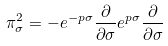<formula> <loc_0><loc_0><loc_500><loc_500>\pi _ { \sigma } ^ { 2 } = - e ^ { - p \sigma } \frac { \partial } { \partial \sigma } e ^ { p \sigma } \frac { \partial } { \partial \sigma }</formula> 